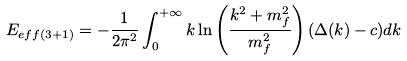Convert formula to latex. <formula><loc_0><loc_0><loc_500><loc_500>E _ { e f f ( 3 + 1 ) } = - \frac { 1 } { 2 \pi ^ { 2 } } \int _ { 0 } ^ { + \infty } k \ln \left ( \frac { k ^ { 2 } + m ^ { 2 } _ { f } } { m _ { f } ^ { 2 } } \right ) ( \Delta ( k ) - c ) d k</formula> 